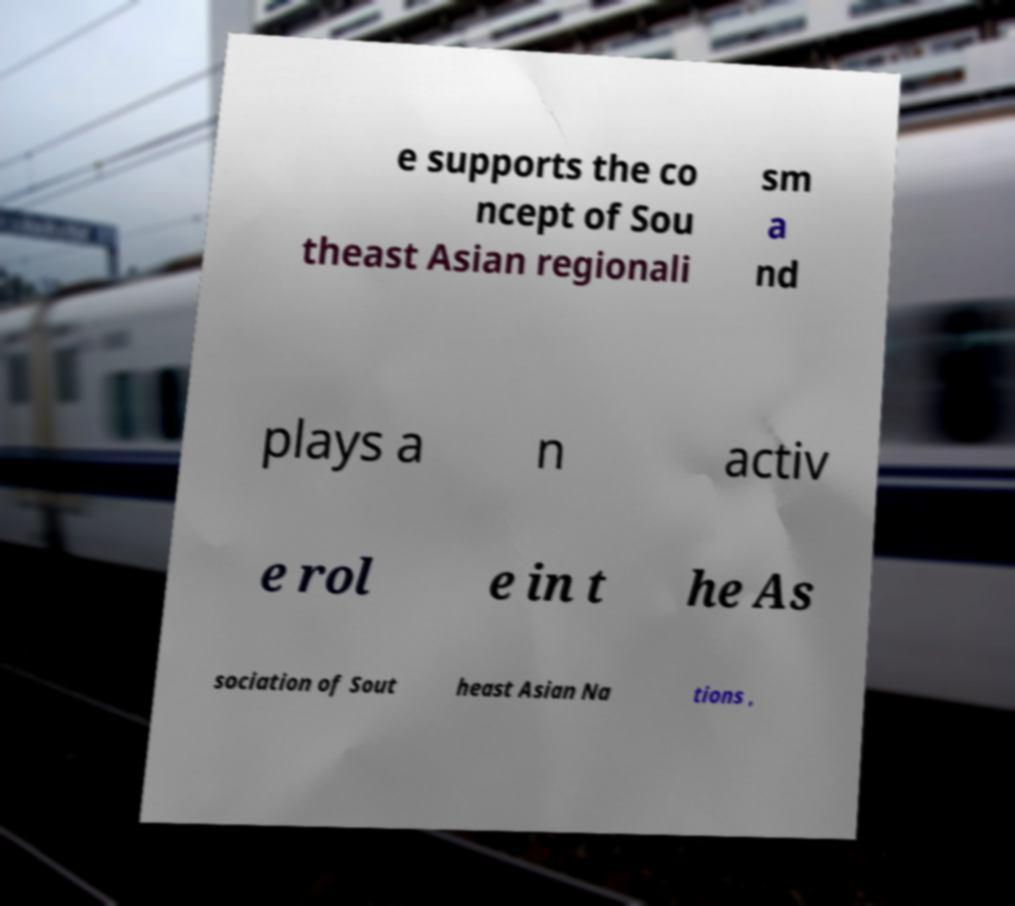Please identify and transcribe the text found in this image. e supports the co ncept of Sou theast Asian regionali sm a nd plays a n activ e rol e in t he As sociation of Sout heast Asian Na tions , 